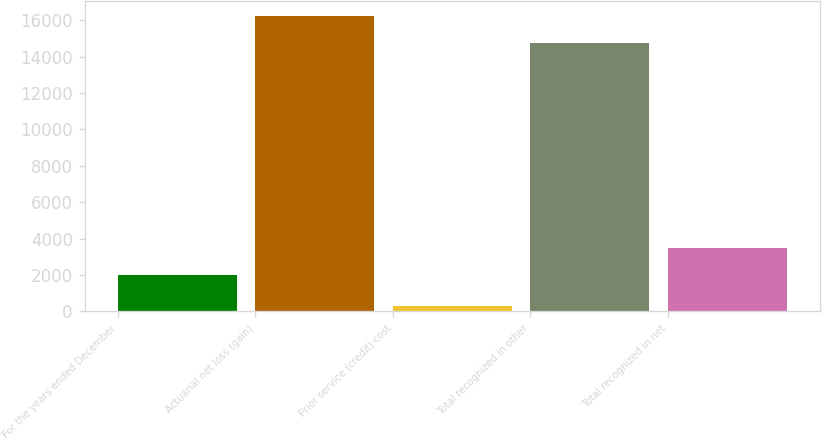Convert chart. <chart><loc_0><loc_0><loc_500><loc_500><bar_chart><fcel>For the years ended December<fcel>Actuarial net loss (gain)<fcel>Prior service (credit) cost<fcel>Total recognized in other<fcel>Total recognized in net<nl><fcel>2010<fcel>16226.1<fcel>293<fcel>14751<fcel>3485.1<nl></chart> 